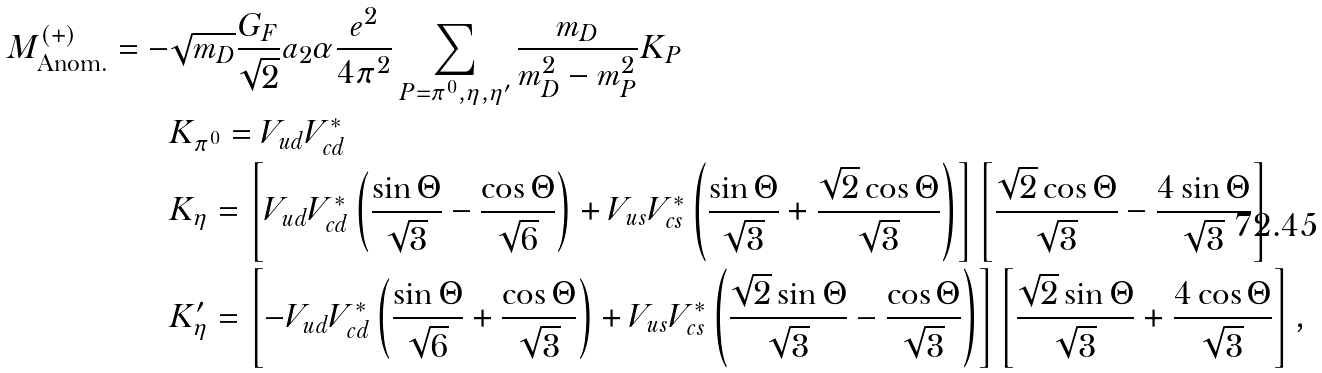Convert formula to latex. <formula><loc_0><loc_0><loc_500><loc_500>M _ { \text {Anom.} } ^ { ( + ) } = - & \sqrt { m _ { D } } \frac { G _ { F } } { \sqrt { 2 } } a _ { 2 } \alpha \frac { e ^ { 2 } } { 4 \pi ^ { 2 } } \sum _ { P = \pi ^ { 0 } , \eta , \eta ^ { \prime } } \frac { m _ { D } } { m _ { D } ^ { 2 } - m _ { P } ^ { 2 } } K _ { P } \\ & K _ { \pi ^ { 0 } } = V _ { u d } V _ { c d } ^ { * } \\ & K _ { \eta } = \left [ V _ { u d } V _ { c d } ^ { * } \left ( \frac { \sin \Theta } { \sqrt { 3 } } - \frac { \cos \Theta } { \sqrt { 6 } } \right ) + V _ { u s } V _ { c s } ^ { * } \left ( \frac { \sin \Theta } { \sqrt { 3 } } + \frac { \sqrt { 2 } \cos \Theta } { \sqrt { 3 } } \right ) \right ] \left [ \frac { \sqrt { 2 } \cos \Theta } { \sqrt { 3 } } - \frac { 4 \sin \Theta } { \sqrt { 3 } } \right ] \\ & K _ { \eta } ^ { \prime } = \left [ - V _ { u d } V _ { c d } ^ { * } \left ( \frac { \sin \Theta } { \sqrt { 6 } } + \frac { \cos \Theta } { \sqrt { 3 } } \right ) + V _ { u s } V _ { c s } ^ { * } \left ( \frac { \sqrt { 2 } \sin \Theta } { \sqrt { 3 } } - \frac { \cos \Theta } { \sqrt { 3 } } \right ) \right ] \left [ \frac { \sqrt { 2 } \sin \Theta } { \sqrt { 3 } } + \frac { 4 \cos \Theta } { \sqrt { 3 } } \right ] ,</formula> 